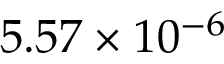Convert formula to latex. <formula><loc_0><loc_0><loc_500><loc_500>5 . 5 7 \times 1 0 ^ { - 6 }</formula> 